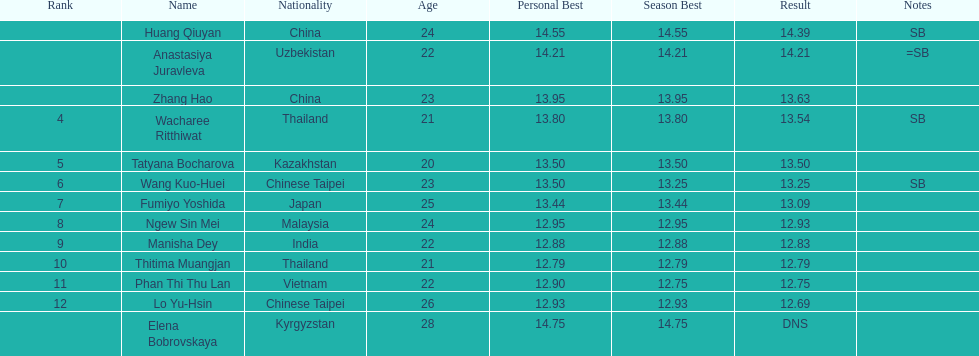How many athletes had a better result than tatyana bocharova? 4. 